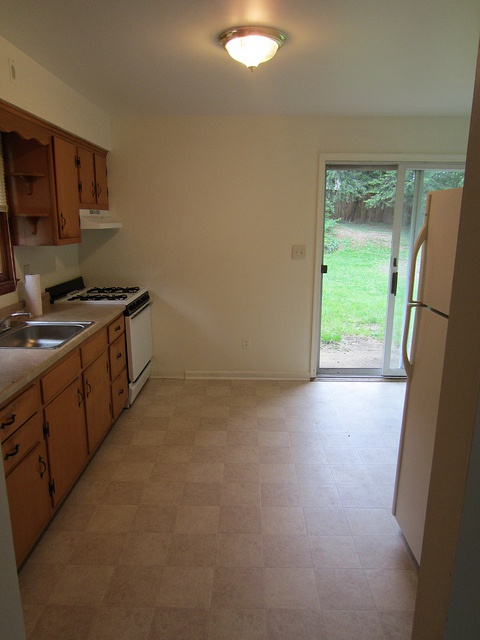Describe the objects in this image and their specific colors. I can see refrigerator in gray and lightblue tones, oven in gray and black tones, sink in gray, black, and darkgray tones, and bottle in gray, darkgray, and maroon tones in this image. 